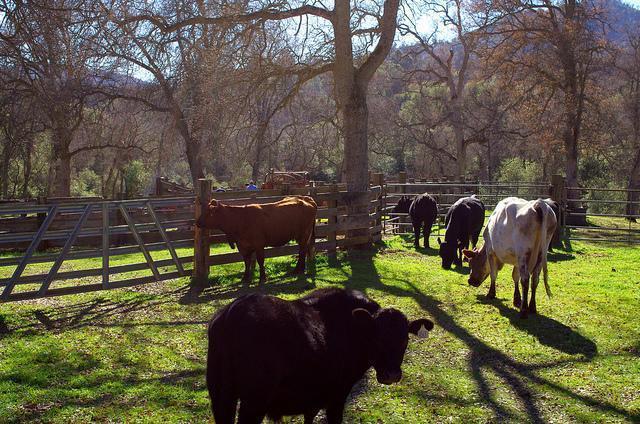How many cows can be seen?
Give a very brief answer. 4. 